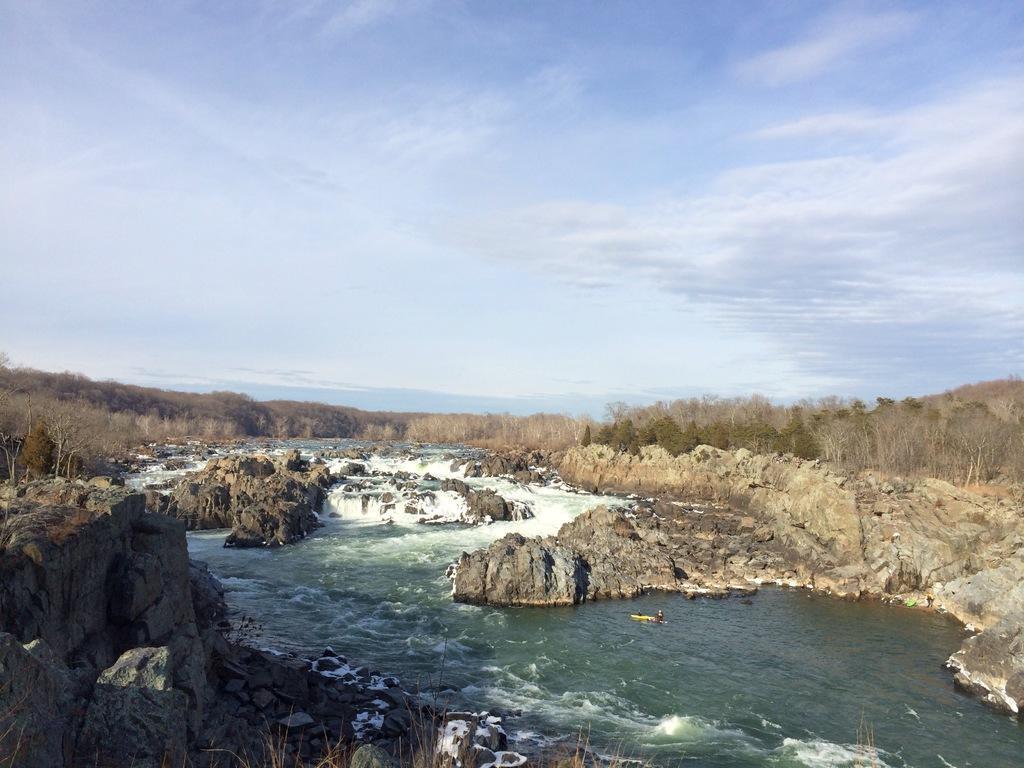Please provide a concise description of this image. In this picture there is water in the center of the image and there are rocks on the right and left side of the image, there are trees in the center of the image. 